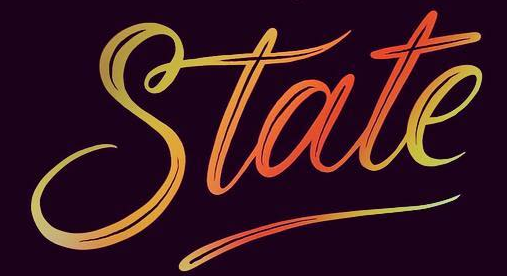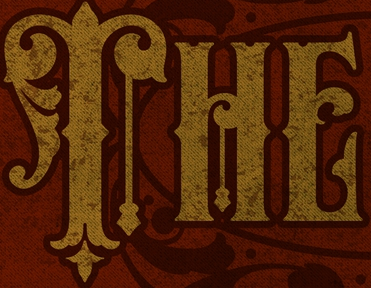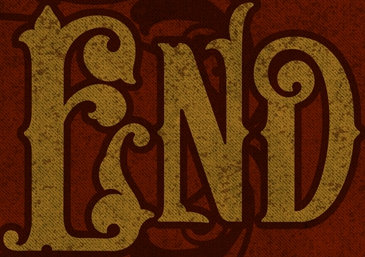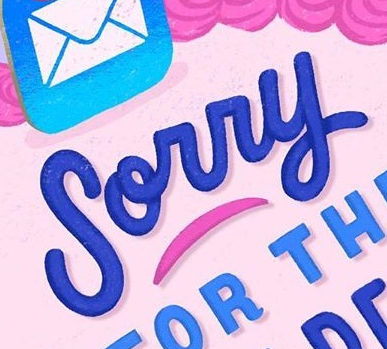Identify the words shown in these images in order, separated by a semicolon. State; THE; END; Sorry 